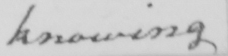What does this handwritten line say? knowing 